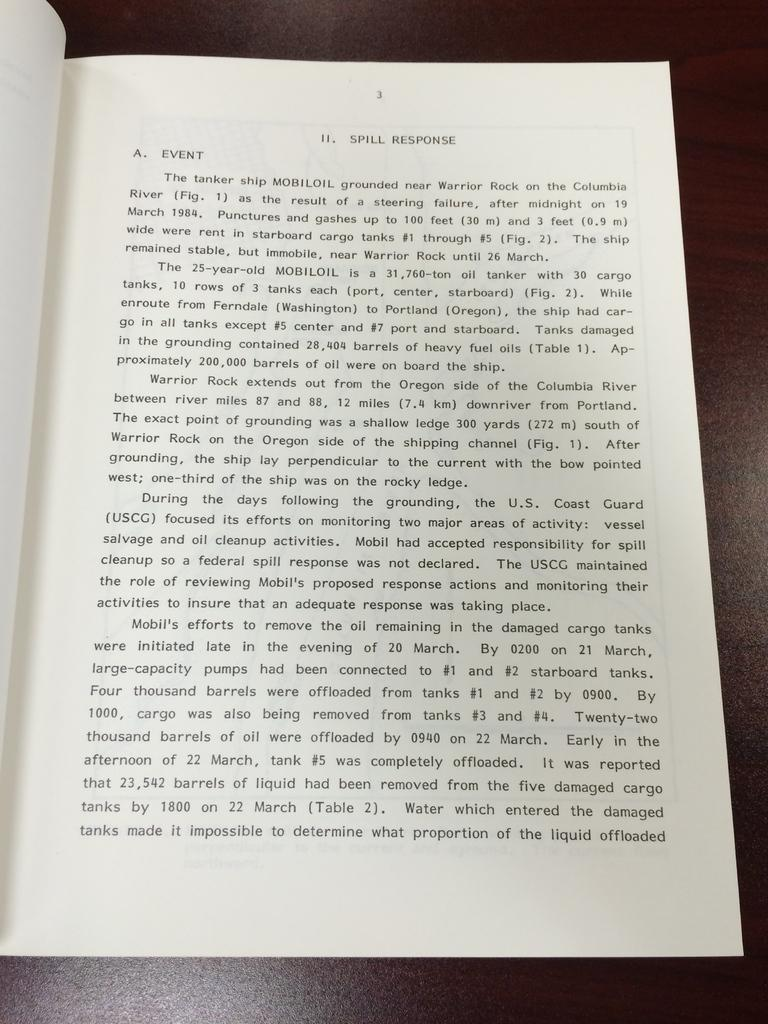<image>
Relay a brief, clear account of the picture shown. A book is open to page three with the top text talking about spill response. 